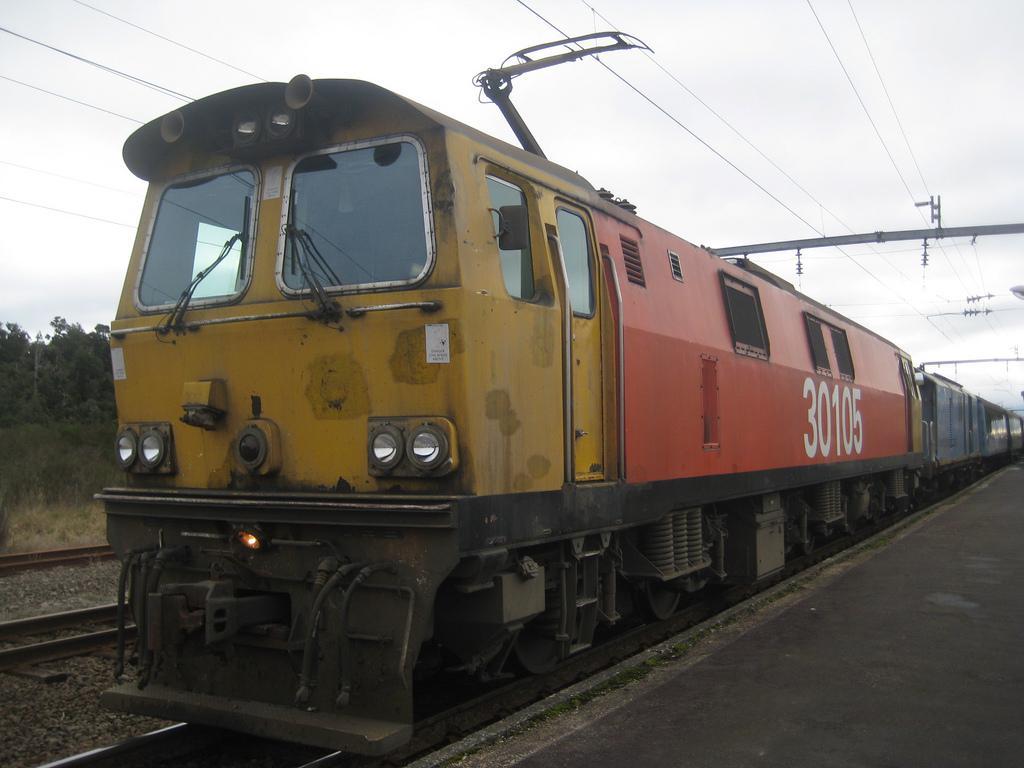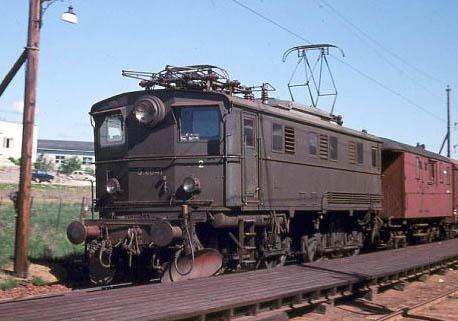The first image is the image on the left, the second image is the image on the right. Examine the images to the left and right. Is the description "The train in both images is yellow and red." accurate? Answer yes or no. No. The first image is the image on the left, the second image is the image on the right. Given the left and right images, does the statement "At least one electric pole is by a train track." hold true? Answer yes or no. Yes. 